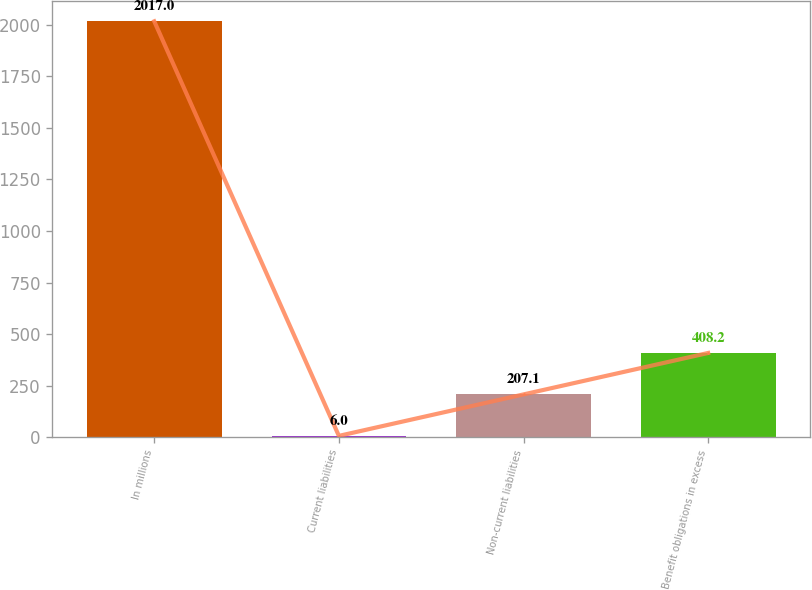<chart> <loc_0><loc_0><loc_500><loc_500><bar_chart><fcel>In millions<fcel>Current liabilities<fcel>Non-current liabilities<fcel>Benefit obligations in excess<nl><fcel>2017<fcel>6<fcel>207.1<fcel>408.2<nl></chart> 